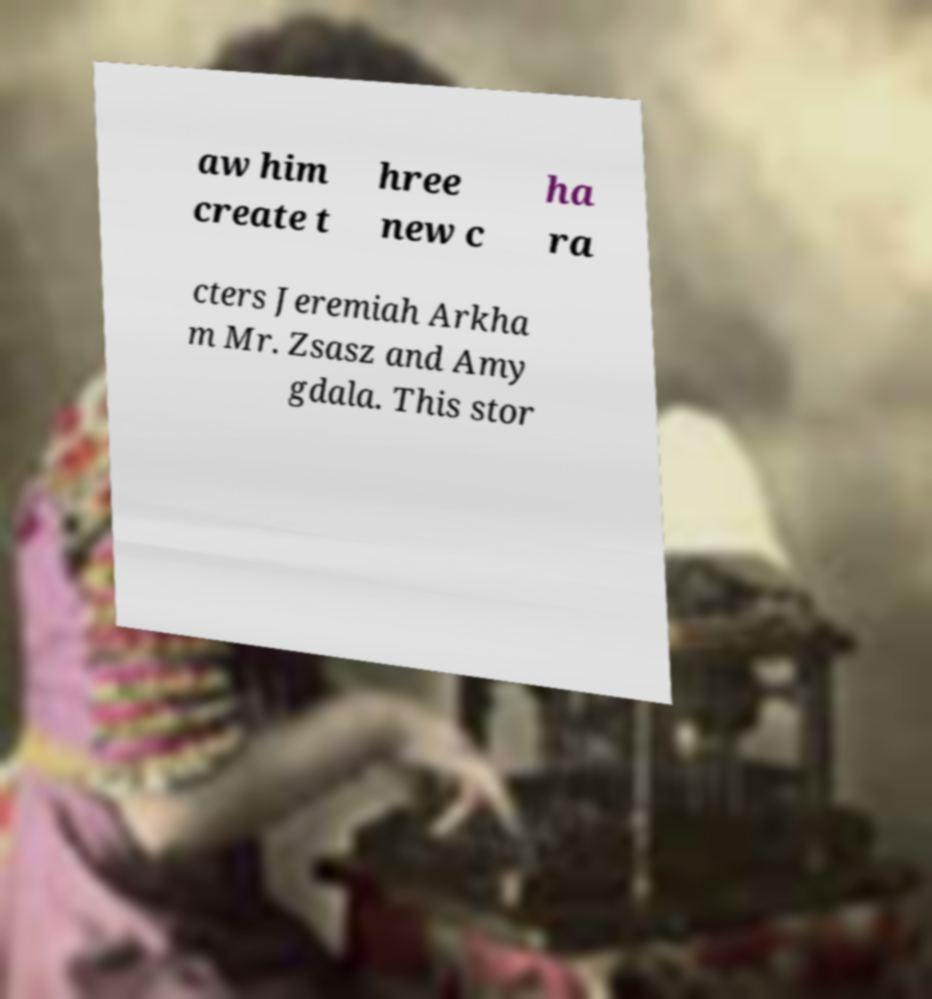Can you read and provide the text displayed in the image?This photo seems to have some interesting text. Can you extract and type it out for me? aw him create t hree new c ha ra cters Jeremiah Arkha m Mr. Zsasz and Amy gdala. This stor 